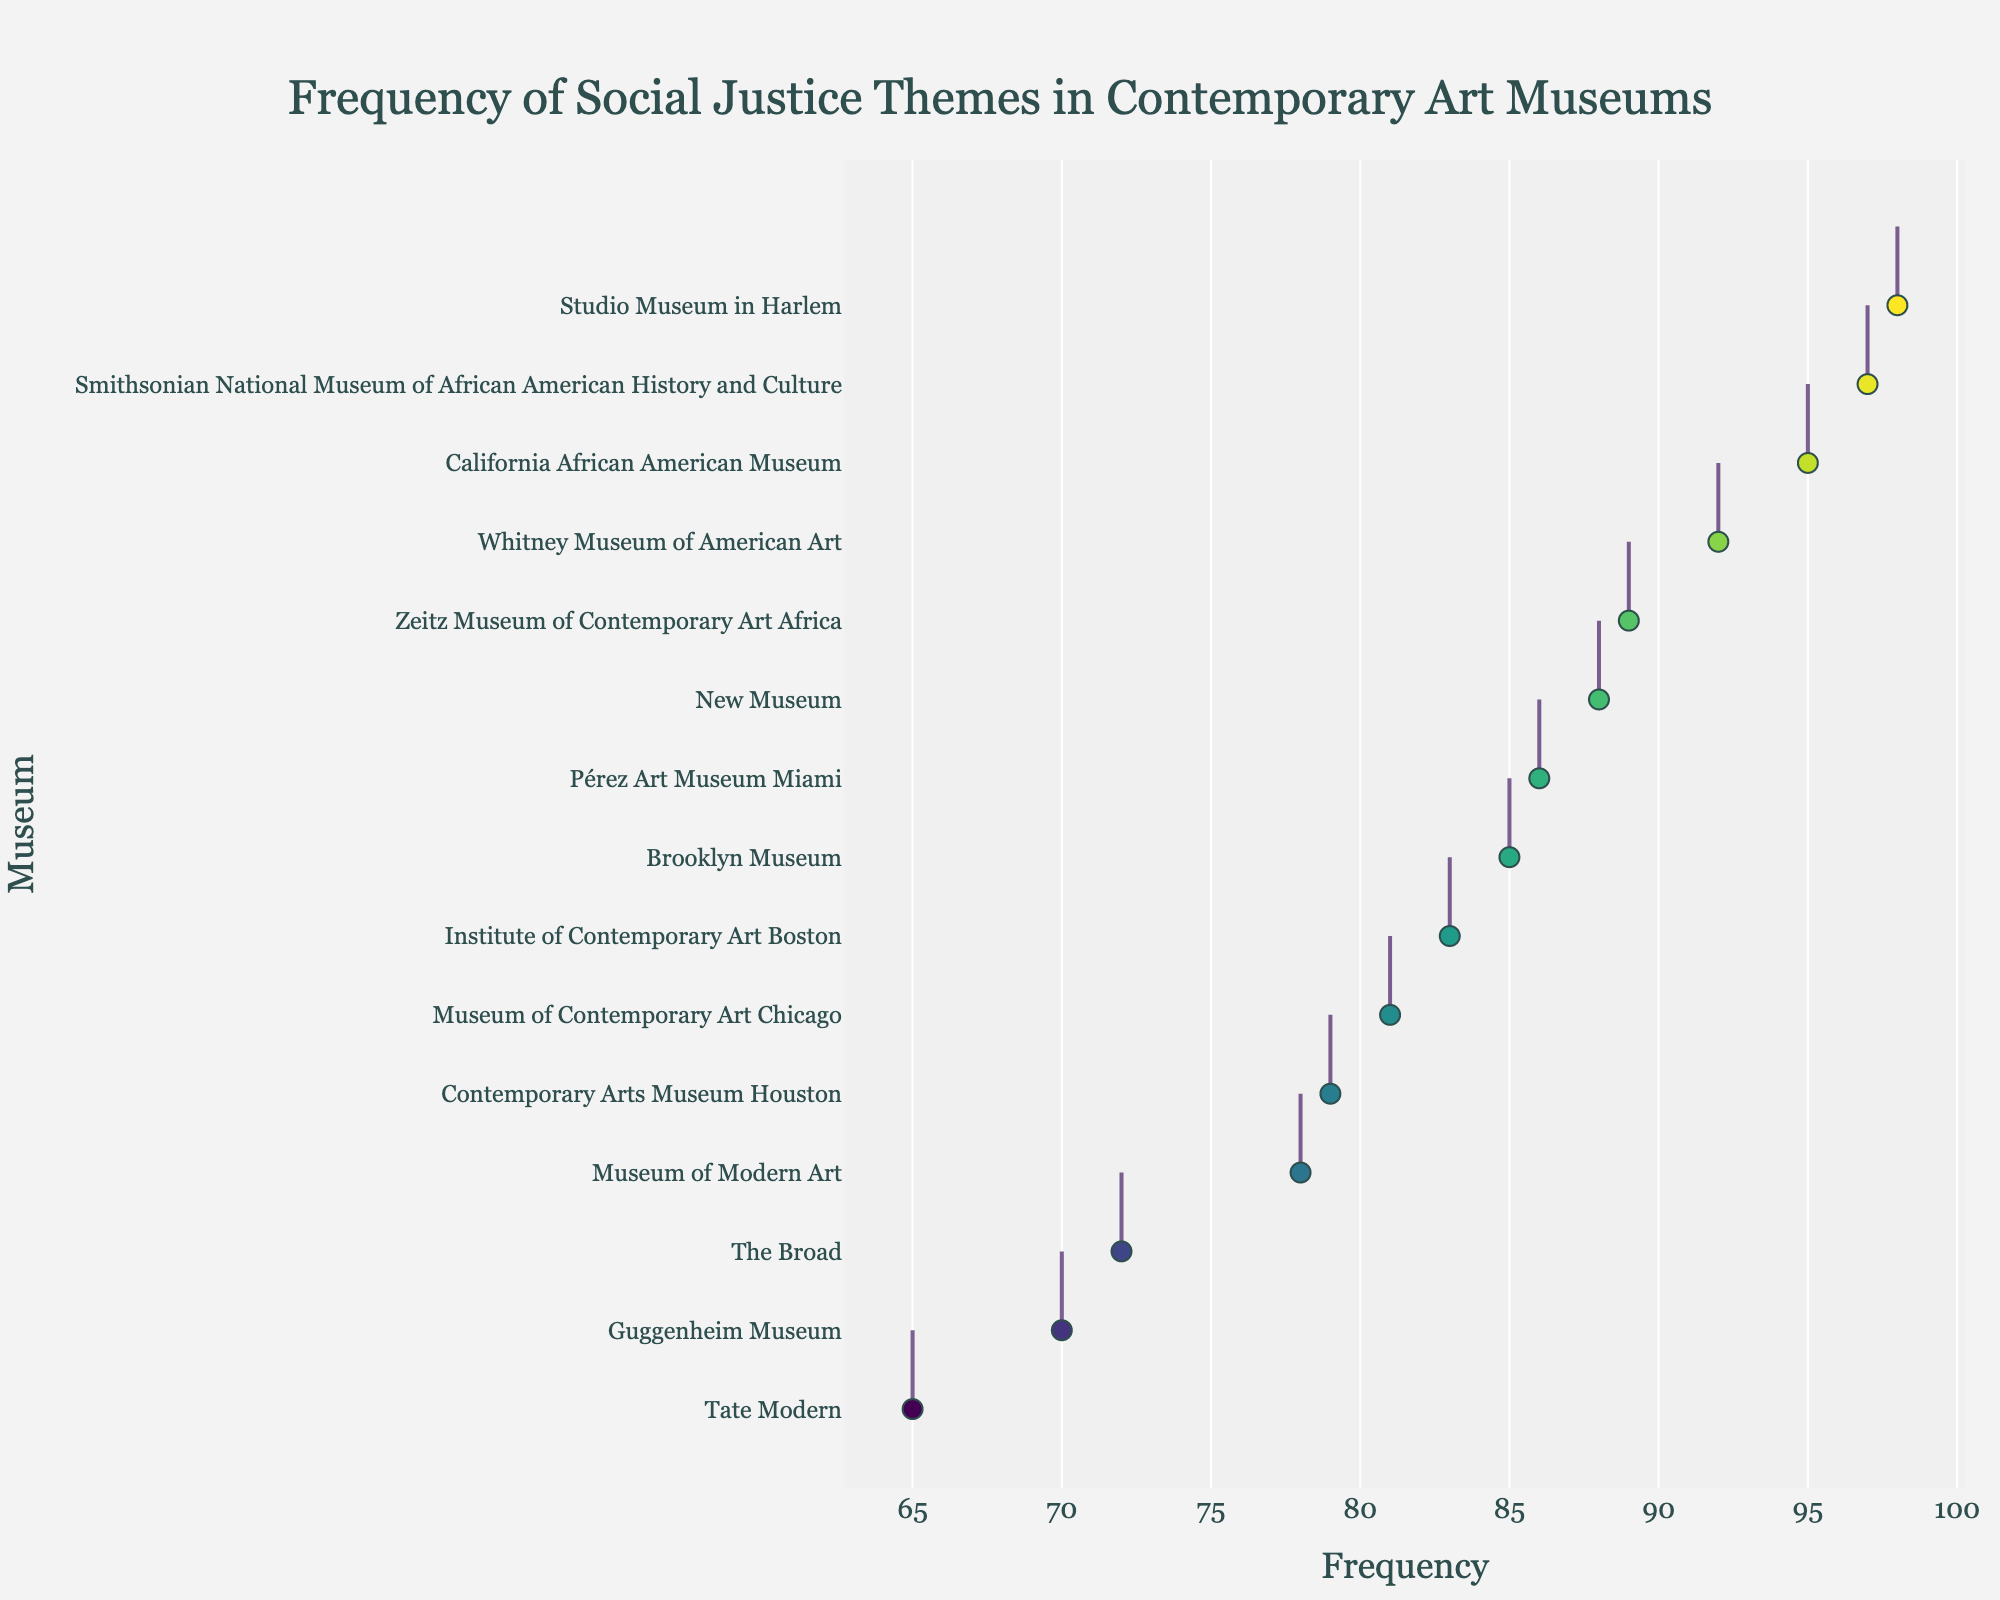What is the title of the figure? The figure's title can be found at the top of the plot. The title provides a summary of what the figure represents. In this case, it describes the theme of the plot.
Answer: Frequency of Social Justice Themes in Contemporary Art Museums Which museum has the highest frequency of artworks addressing social justice themes? To determine this, identify the museum name corresponding to the highest frequency value in the horizontal density plot. The museum with the highest frequency value is at the top of the plot.
Answer: Studio Museum in Harlem What is the range of frequencies represented in the plot? The range can be found by identifying the smallest and largest values on the x-axis. The range is the difference between these two values.
Answer: 65-98 How many museums have frequencies between 80 and 90? Count the number of museum names that correspond to frequency values within the range of 80 to 90 on the x-axis.
Answer: 6 Which museums have frequencies higher than 90? Identify all the museum names that correspond to frequency values greater than 90 on the x-axis.
Answer: Studio Museum in Harlem, California African American Museum, and Smithsonian National Museum of African American History and Culture What is the average frequency of the museums listed? To find the average, sum all the frequency values, then divide by the number of museums.
Answer: (78 + 65 + 92 + 85 + 98 + 95 + 89 + 97 + 72 + 88 + 70 + 83 + 79 + 81 + 86) / 15 = 84.8 Which museums lie at the extremes of frequency, i.e., have the minimum and maximum values? The extremes are indicated by the lowest and highest points on the x-axis. Find the corresponding museum names.
Answer: Tate Modern and Studio Museum in Harlem How many museums have frequencies less than 80? Count the number of museum names with frequency values less than 80 based on the plot.
Answer: 3 Which museum has a frequency closest to 90? Identify the frequency values around 90 and determine which museum’s frequency is closest to this value.
Answer: Zeitz Museum of Contemporary Art Africa Is there a museum with a frequency exactly equal to 95? Check if there's a dot lying exactly on the frequency value of 95 on the x-axis and identify the corresponding museum name.
Answer: California African American Museum 